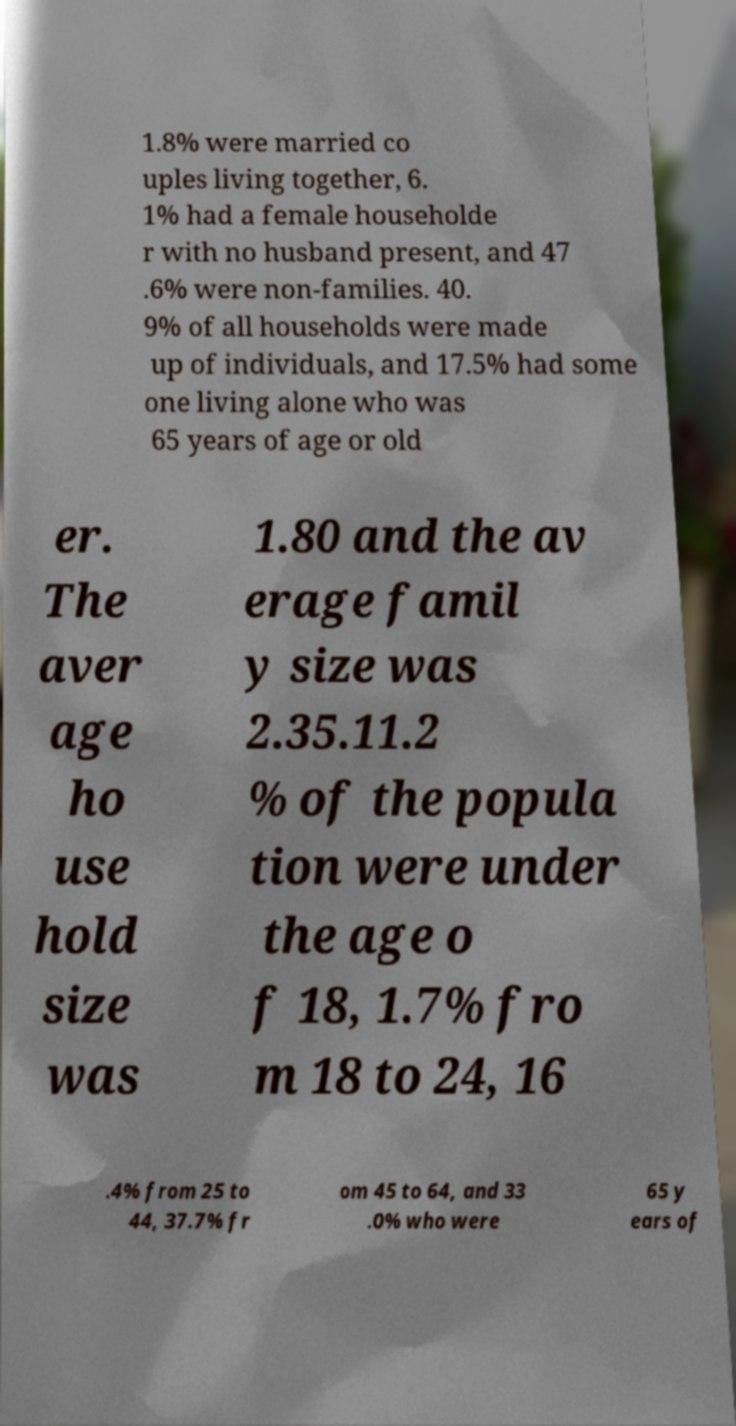Could you extract and type out the text from this image? 1.8% were married co uples living together, 6. 1% had a female householde r with no husband present, and 47 .6% were non-families. 40. 9% of all households were made up of individuals, and 17.5% had some one living alone who was 65 years of age or old er. The aver age ho use hold size was 1.80 and the av erage famil y size was 2.35.11.2 % of the popula tion were under the age o f 18, 1.7% fro m 18 to 24, 16 .4% from 25 to 44, 37.7% fr om 45 to 64, and 33 .0% who were 65 y ears of 